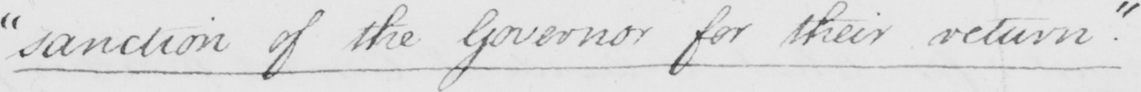What text is written in this handwritten line? " sanction of the Governor for their return . " 